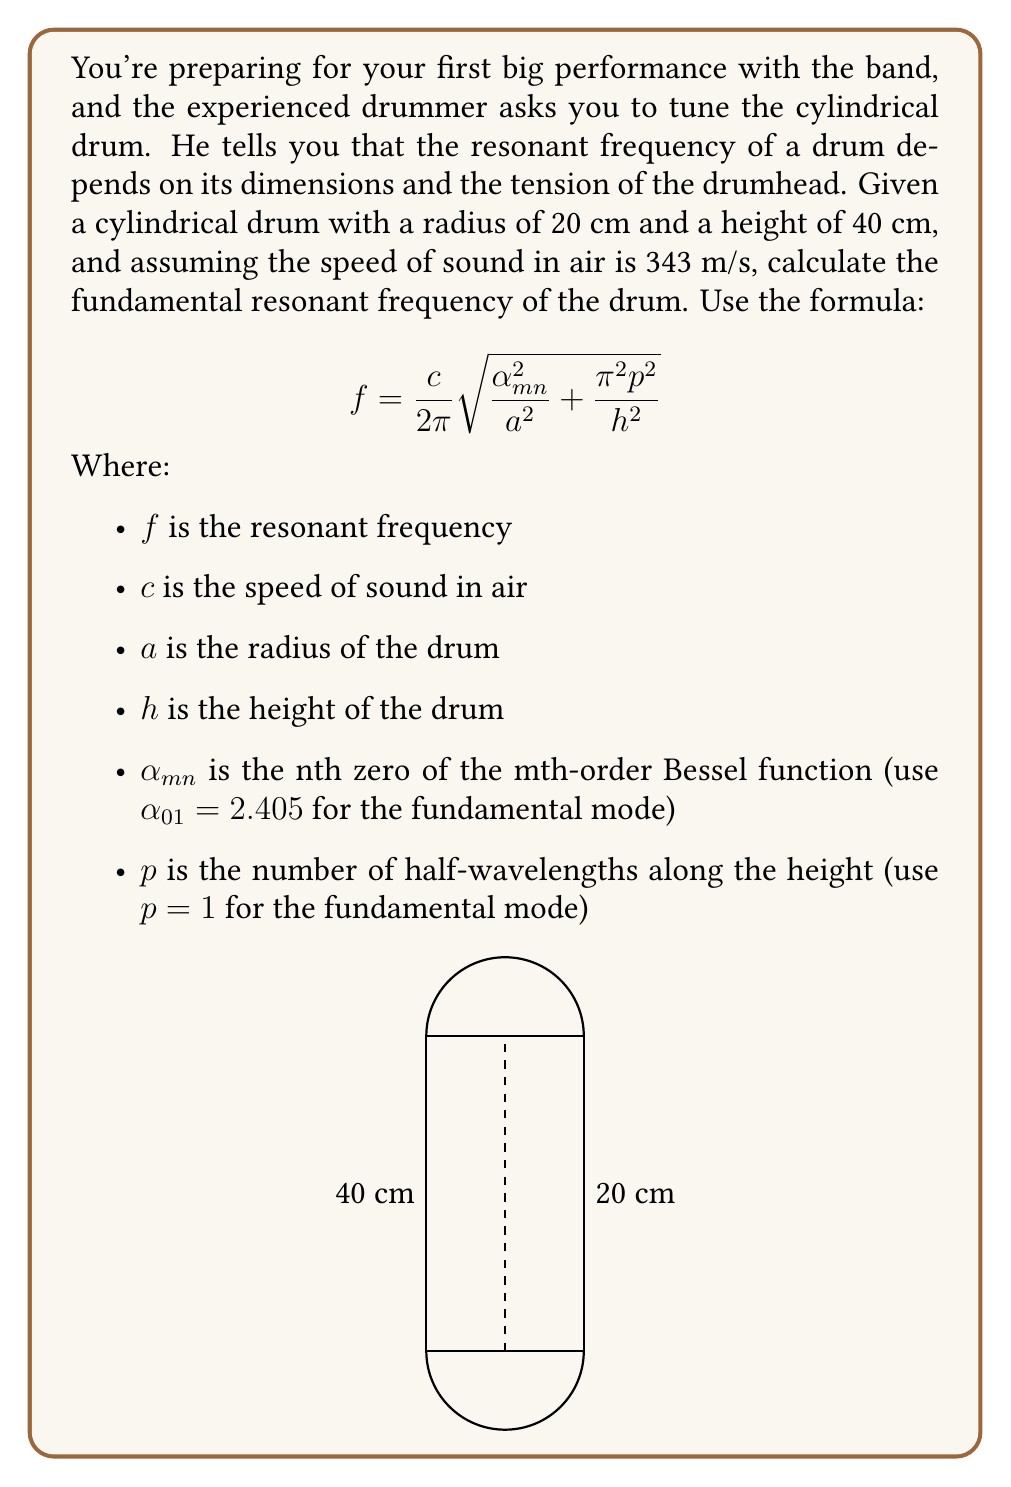Give your solution to this math problem. Let's solve this step-by-step:

1) We're given:
   $c = 343$ m/s
   $a = 20$ cm = 0.2 m
   $h = 40$ cm = 0.4 m
   $\alpha_{01} = 2.405$
   $p = 1$

2) Let's substitute these values into the formula:

   $$f = \frac{343}{2\pi}\sqrt{\frac{2.405^2}{0.2^2} + \frac{\pi^2 1^2}{0.4^2}}$$

3) Let's simplify inside the square root first:

   $$\frac{2.405^2}{0.2^2} = \frac{5.784025}{0.04} = 144.600625$$

   $$\frac{\pi^2 1^2}{0.4^2} = \frac{\pi^2}{0.16} = 61.685027$$

4) Now our equation looks like:

   $$f = \frac{343}{2\pi}\sqrt{144.600625 + 61.685027}$$

5) Simplify under the square root:

   $$f = \frac{343}{2\pi}\sqrt{206.285652}$$

6) Calculate the square root:

   $$f = \frac{343}{2\pi} * 14.362868$$

7) Multiply:

   $$f = 783.461 \text{ Hz}$$

8) Round to the nearest whole number:

   $$f \approx 783 \text{ Hz}$$
Answer: 783 Hz 